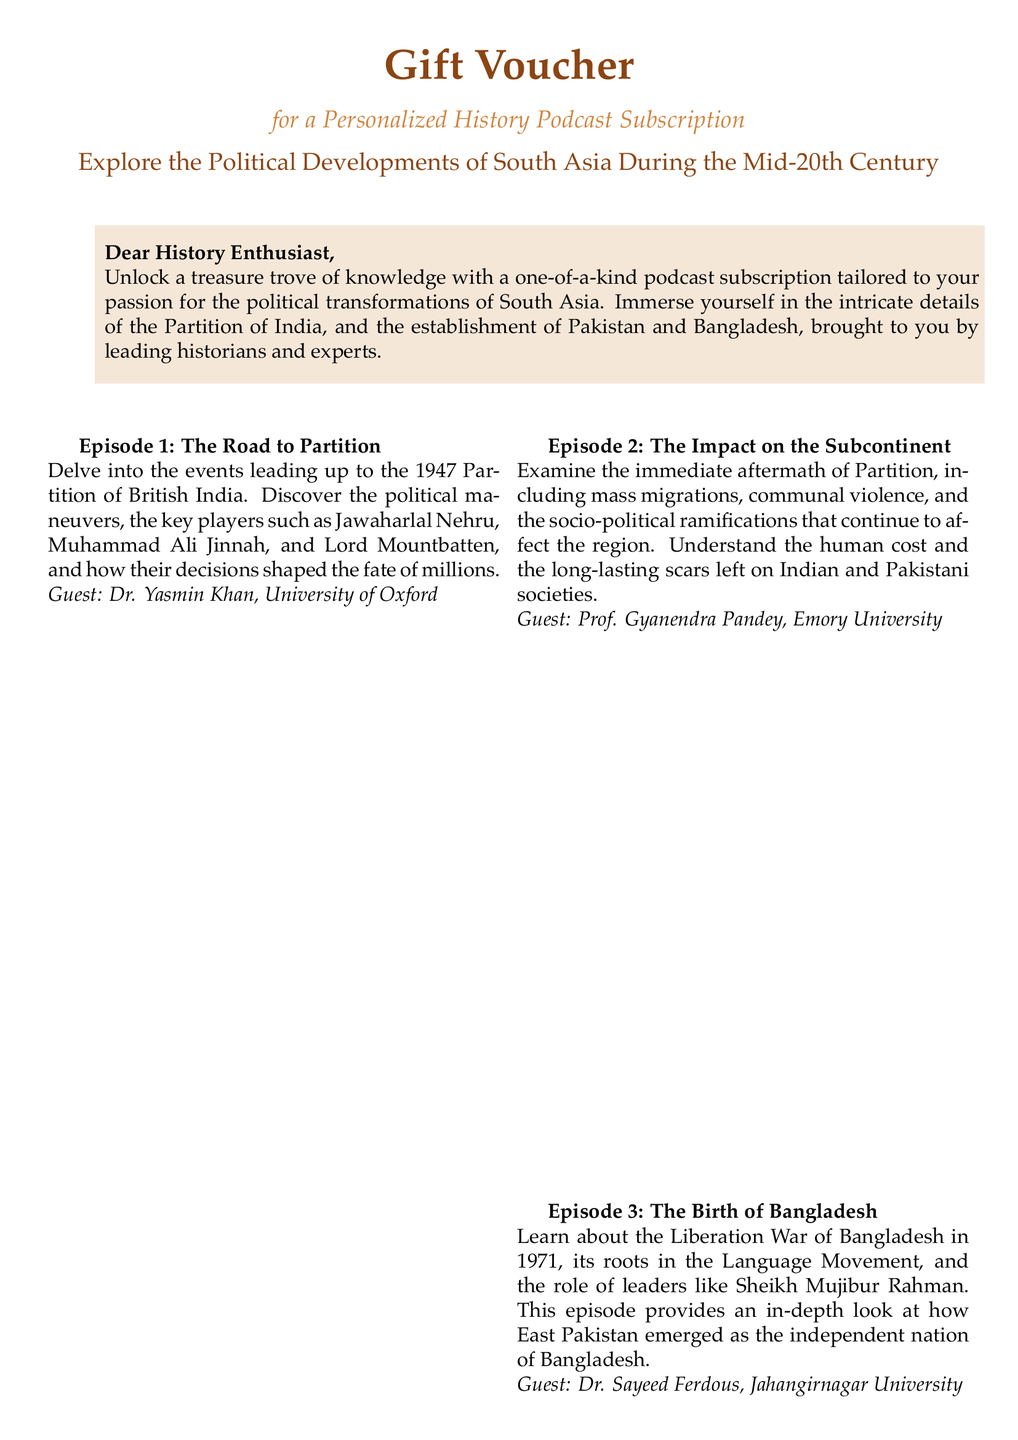What is the title of the podcast series? The title of the podcast series mentioned in the voucher is "History With Experts."
Answer: History With Experts Who is the guest for Episode 1? The guest for Episode 1, titled "The Road to Partition," is Dr. Yasmin Khan from the University of Oxford.
Answer: Dr. Yasmin Khan How many months is the subscription valid for? The voucher states that it entitles the holder to a subscription valid for 12 months.
Answer: 12 months What is the voucher code? The voucher code provided in the document is HS2023SA.
Answer: HS2023SA Who is the guest for the episode regarding the Liberation War of Bangladesh? The guest for the episode titled "The Birth of Bangladesh" is Dr. Sayeed Ferdous from Jahangirnagar University.
Answer: Dr. Sayeed Ferdous What are the terms for the voucher? The terms state that the voucher is non-transferable and non-refundable.
Answer: Non-transferable and non-refundable What color is used for the main heading on the gift voucher? The main heading, "Gift Voucher," features a color defined as maincolor (RGB: 139,69,19).
Answer: maincolor What is the theme of the podcast subscription? The theme of the podcast subscription revolves around the political developments of South Asia during the mid-20th century.
Answer: Political developments of South Asia during the mid-20th century 